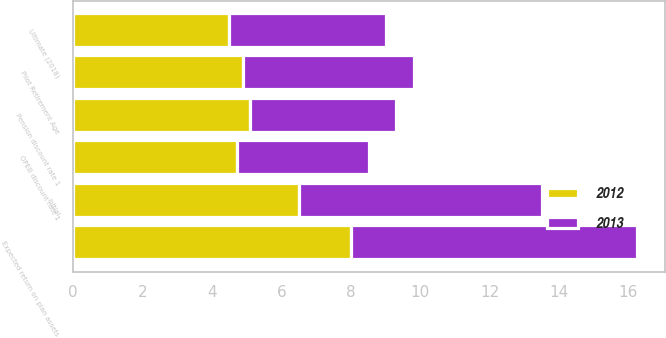Convert chart to OTSL. <chart><loc_0><loc_0><loc_500><loc_500><stacked_bar_chart><ecel><fcel>Pension discount rate 1<fcel>OPEB discount rate 1<fcel>Expected return on plan assets<fcel>Initial<fcel>Ultimate (2018)<fcel>Pilot Retirement Age<nl><fcel>2012<fcel>5.1<fcel>4.71<fcel>8<fcel>6.5<fcel>4.5<fcel>4.905<nl><fcel>2013<fcel>4.2<fcel>3.8<fcel>8.25<fcel>7<fcel>4.5<fcel>4.905<nl></chart> 